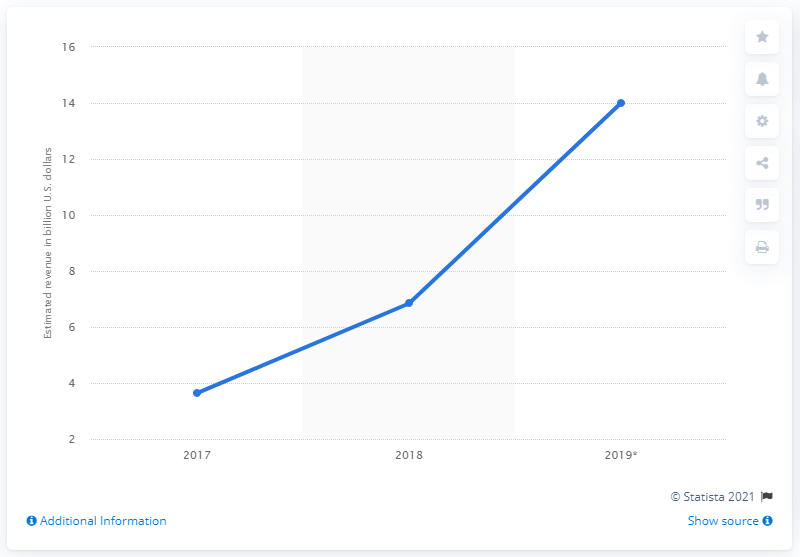Identify some key points in this picture. The projected revenue of Instagram in 2019 is approximately 14. In 2018, Instagram generated approximately 6.84 billion US dollars in revenue. 